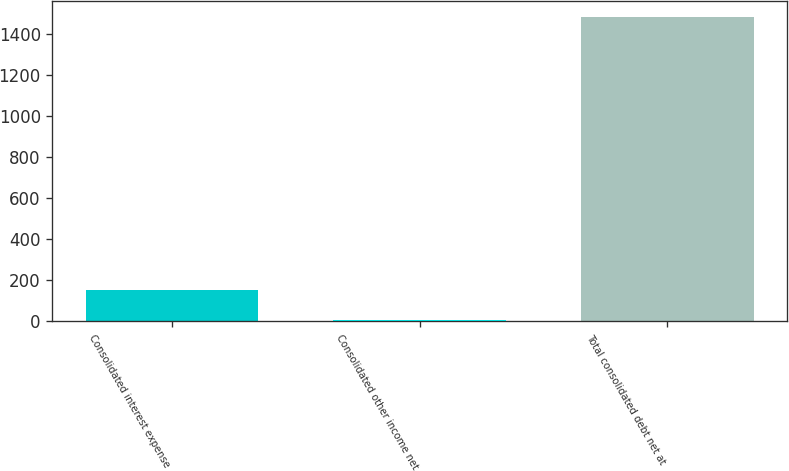Convert chart to OTSL. <chart><loc_0><loc_0><loc_500><loc_500><bar_chart><fcel>Consolidated interest expense<fcel>Consolidated other income net<fcel>Total consolidated debt net at<nl><fcel>152.14<fcel>4.1<fcel>1484.5<nl></chart> 